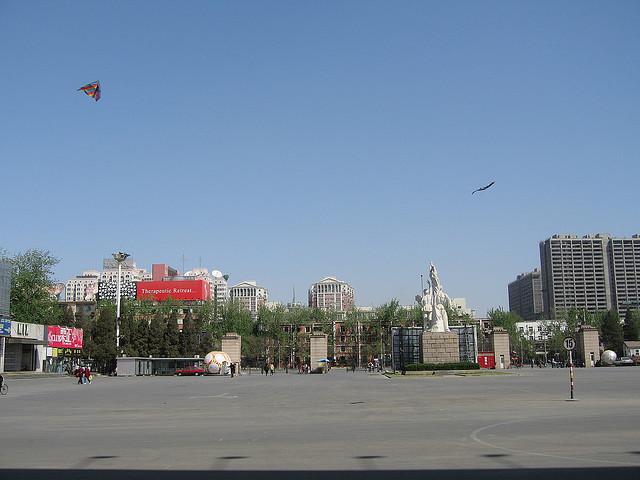How many red cars are on the street?
Be succinct. 1. Are there mountains in this picture?
Write a very short answer. No. What is flying in the sky?
Answer briefly. Kite. Was this photo taken in the afternoon?
Concise answer only. Yes. Are there any people or animals in this scene?
Answer briefly. Yes. How many shadows are in the picture?
Quick response, please. 5. What is the weather like?
Quick response, please. Clear. Is it cloudy?
Concise answer only. No. Is it daytime?
Write a very short answer. Yes. Is the sky cloudy?
Give a very brief answer. No. Is it a cloudy day?
Keep it brief. No. Is the sky blue or cloudy?
Quick response, please. Blue. Is this a residential area?
Keep it brief. No. Is this a highway?
Short answer required. No. Is it sunny?
Answer briefly. Yes. 